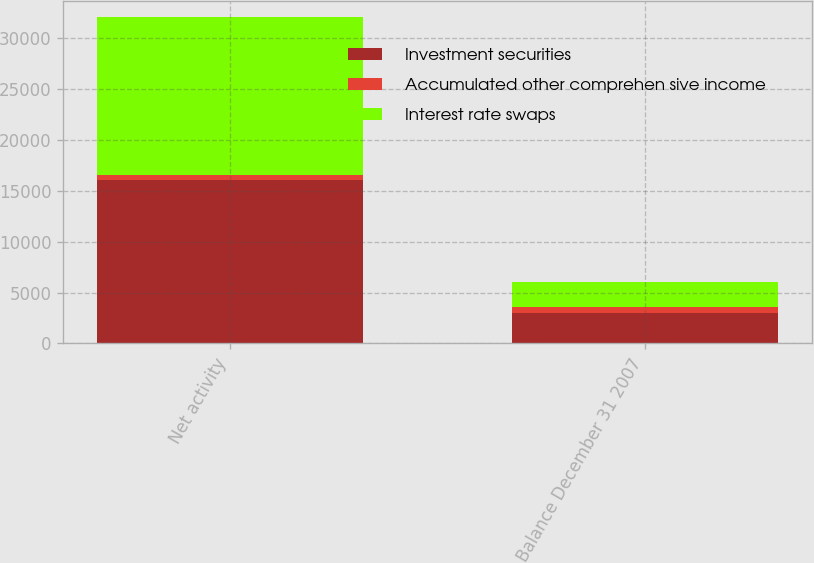Convert chart to OTSL. <chart><loc_0><loc_0><loc_500><loc_500><stacked_bar_chart><ecel><fcel>Net activity<fcel>Balance December 31 2007<nl><fcel>Investment securities<fcel>16027<fcel>3030<nl><fcel>Accumulated other comprehen sive income<fcel>519<fcel>519<nl><fcel>Interest rate swaps<fcel>15508<fcel>2511<nl></chart> 